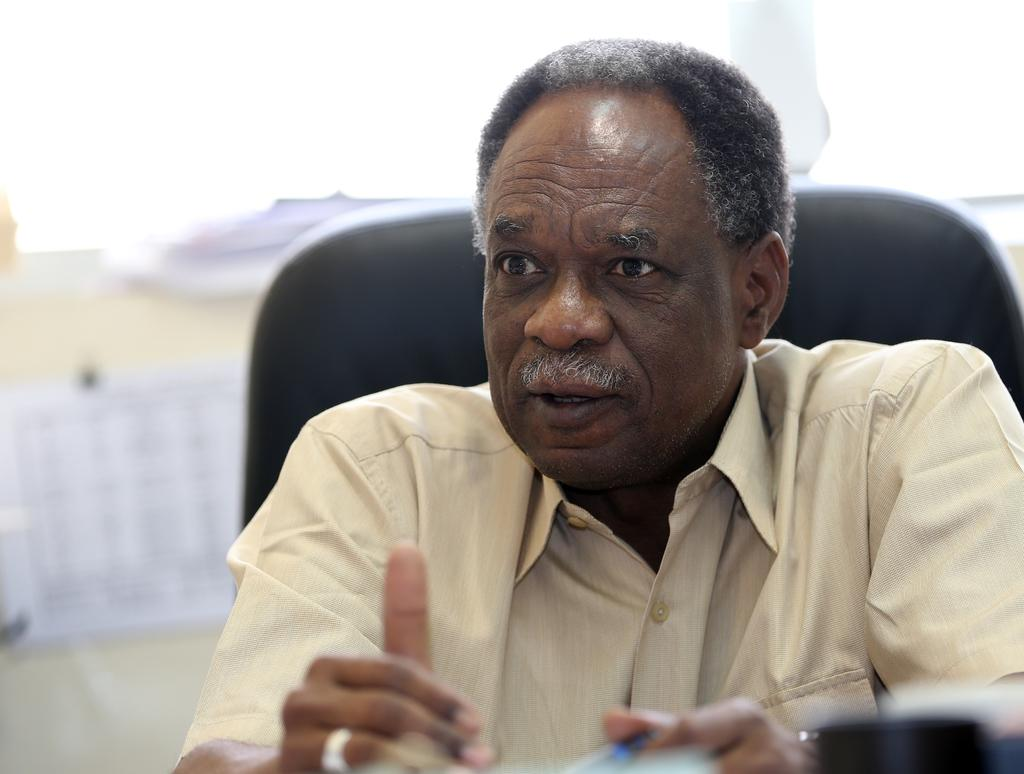What is present in the image? There is a man in the image. What is the man doing in the image? The man is talking. What is the man wearing in the image? The man is wearing a shirt. Where is the kettle located in the image? There is no kettle present in the image. What type of cattle can be seen grazing in the background of the image? There is no cattle present in the image. 